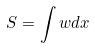<formula> <loc_0><loc_0><loc_500><loc_500>S = \int w d x</formula> 